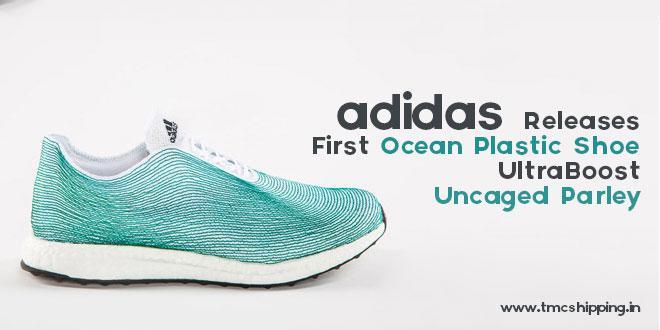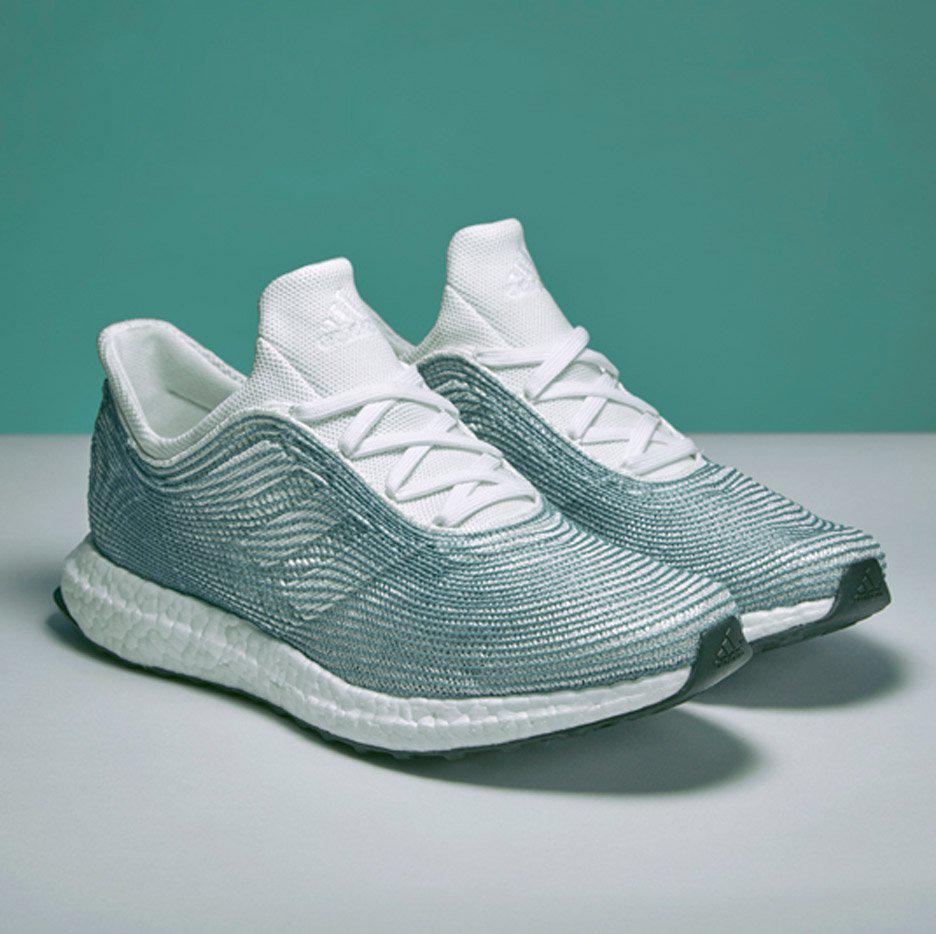The first image is the image on the left, the second image is the image on the right. Considering the images on both sides, is "An image shows blue sneakers posed with a tangle of fibrous strings." valid? Answer yes or no. No. The first image is the image on the left, the second image is the image on the right. Evaluate the accuracy of this statement regarding the images: "There are more than three shoes.". Is it true? Answer yes or no. No. 